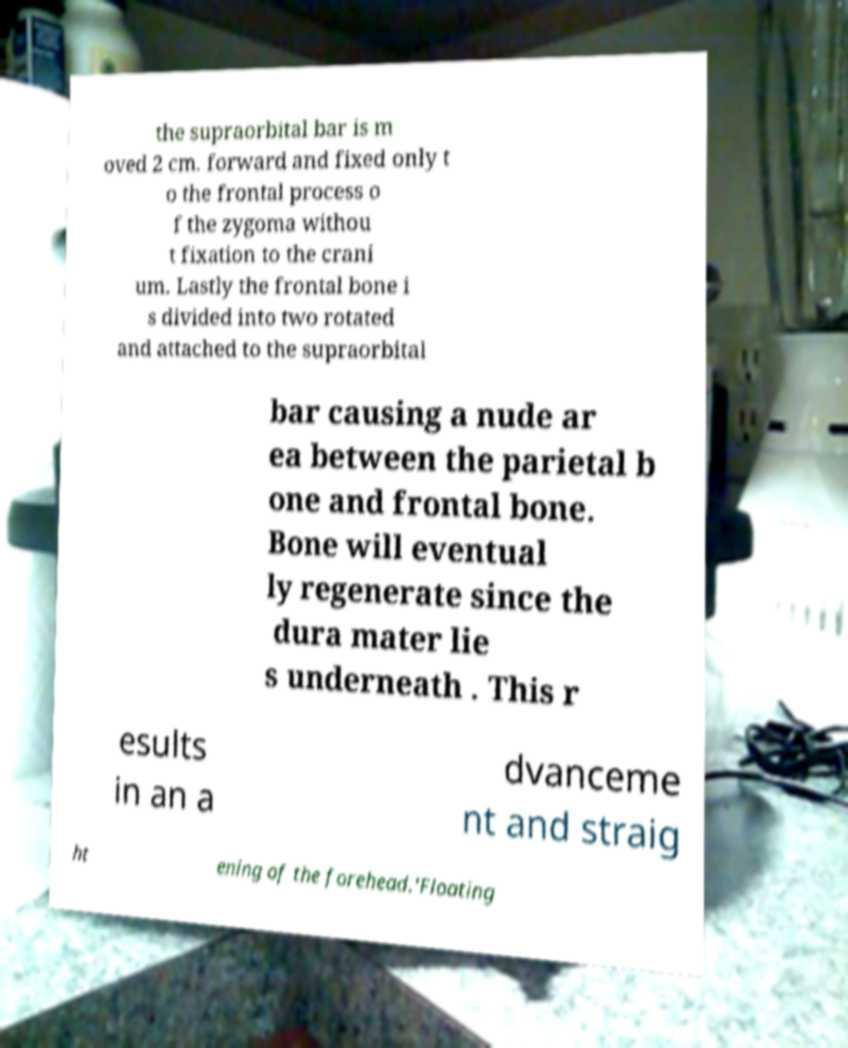Can you read and provide the text displayed in the image?This photo seems to have some interesting text. Can you extract and type it out for me? the supraorbital bar is m oved 2 cm. forward and fixed only t o the frontal process o f the zygoma withou t fixation to the crani um. Lastly the frontal bone i s divided into two rotated and attached to the supraorbital bar causing a nude ar ea between the parietal b one and frontal bone. Bone will eventual ly regenerate since the dura mater lie s underneath . This r esults in an a dvanceme nt and straig ht ening of the forehead.'Floating 